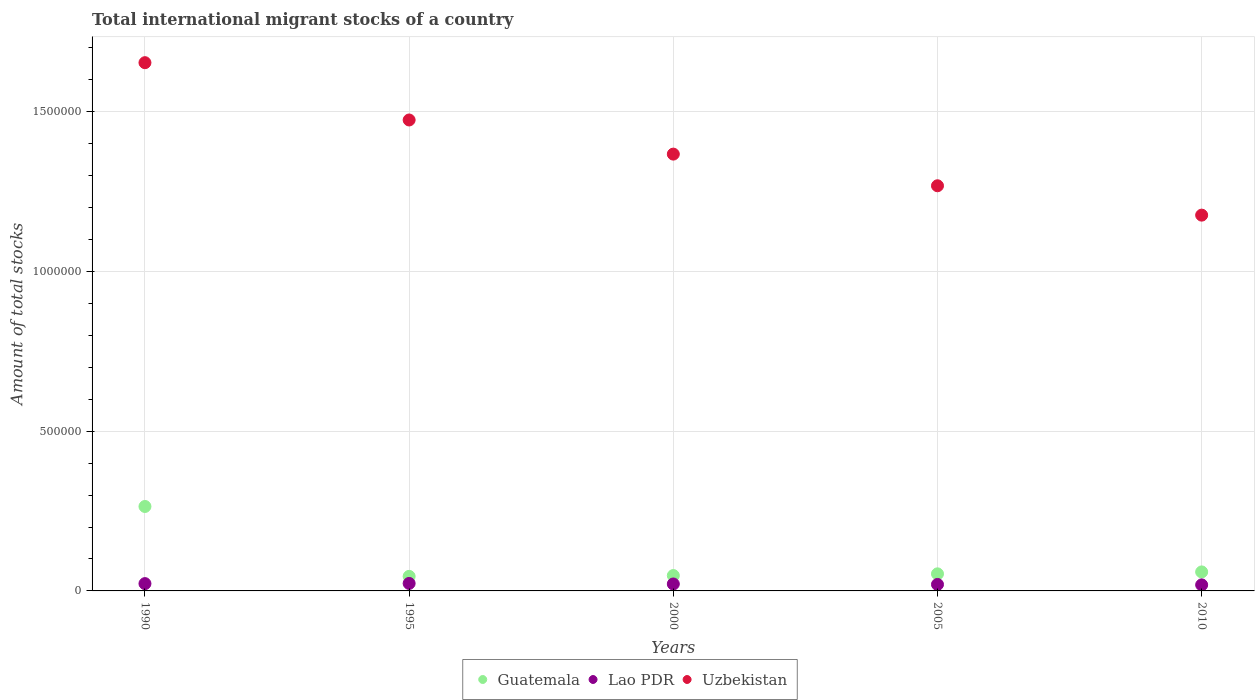How many different coloured dotlines are there?
Provide a short and direct response. 3. Is the number of dotlines equal to the number of legend labels?
Make the answer very short. Yes. What is the amount of total stocks in in Guatemala in 1990?
Ensure brevity in your answer.  2.64e+05. Across all years, what is the maximum amount of total stocks in in Guatemala?
Offer a very short reply. 2.64e+05. Across all years, what is the minimum amount of total stocks in in Guatemala?
Your response must be concise. 4.55e+04. In which year was the amount of total stocks in in Lao PDR minimum?
Offer a very short reply. 2010. What is the total amount of total stocks in in Lao PDR in the graph?
Your answer should be very brief. 1.07e+05. What is the difference between the amount of total stocks in in Uzbekistan in 1990 and that in 2010?
Offer a very short reply. 4.77e+05. What is the difference between the amount of total stocks in in Uzbekistan in 2000 and the amount of total stocks in in Lao PDR in 2010?
Offer a terse response. 1.35e+06. What is the average amount of total stocks in in Guatemala per year?
Your response must be concise. 9.42e+04. In the year 2005, what is the difference between the amount of total stocks in in Uzbekistan and amount of total stocks in in Guatemala?
Your response must be concise. 1.21e+06. What is the ratio of the amount of total stocks in in Guatemala in 2000 to that in 2010?
Provide a short and direct response. 0.81. What is the difference between the highest and the second highest amount of total stocks in in Guatemala?
Your response must be concise. 2.05e+05. What is the difference between the highest and the lowest amount of total stocks in in Lao PDR?
Provide a short and direct response. 4529. Is it the case that in every year, the sum of the amount of total stocks in in Lao PDR and amount of total stocks in in Uzbekistan  is greater than the amount of total stocks in in Guatemala?
Your answer should be very brief. Yes. Does the amount of total stocks in in Lao PDR monotonically increase over the years?
Offer a very short reply. No. What is the difference between two consecutive major ticks on the Y-axis?
Your answer should be very brief. 5.00e+05. Are the values on the major ticks of Y-axis written in scientific E-notation?
Your response must be concise. No. How many legend labels are there?
Provide a succinct answer. 3. How are the legend labels stacked?
Give a very brief answer. Horizontal. What is the title of the graph?
Give a very brief answer. Total international migrant stocks of a country. Does "Turkmenistan" appear as one of the legend labels in the graph?
Make the answer very short. No. What is the label or title of the Y-axis?
Make the answer very short. Amount of total stocks. What is the Amount of total stocks in Guatemala in 1990?
Keep it short and to the point. 2.64e+05. What is the Amount of total stocks of Lao PDR in 1990?
Provide a short and direct response. 2.29e+04. What is the Amount of total stocks in Uzbekistan in 1990?
Your answer should be compact. 1.65e+06. What is the Amount of total stocks of Guatemala in 1995?
Offer a very short reply. 4.55e+04. What is the Amount of total stocks of Lao PDR in 1995?
Make the answer very short. 2.34e+04. What is the Amount of total stocks of Uzbekistan in 1995?
Ensure brevity in your answer.  1.47e+06. What is the Amount of total stocks in Guatemala in 2000?
Provide a short and direct response. 4.81e+04. What is the Amount of total stocks in Lao PDR in 2000?
Offer a terse response. 2.17e+04. What is the Amount of total stocks of Uzbekistan in 2000?
Offer a very short reply. 1.37e+06. What is the Amount of total stocks of Guatemala in 2005?
Your response must be concise. 5.34e+04. What is the Amount of total stocks of Lao PDR in 2005?
Your answer should be very brief. 2.03e+04. What is the Amount of total stocks in Uzbekistan in 2005?
Your answer should be compact. 1.27e+06. What is the Amount of total stocks of Guatemala in 2010?
Your answer should be very brief. 5.95e+04. What is the Amount of total stocks in Lao PDR in 2010?
Offer a terse response. 1.89e+04. What is the Amount of total stocks of Uzbekistan in 2010?
Your response must be concise. 1.18e+06. Across all years, what is the maximum Amount of total stocks of Guatemala?
Offer a terse response. 2.64e+05. Across all years, what is the maximum Amount of total stocks of Lao PDR?
Your answer should be compact. 2.34e+04. Across all years, what is the maximum Amount of total stocks in Uzbekistan?
Offer a very short reply. 1.65e+06. Across all years, what is the minimum Amount of total stocks in Guatemala?
Your response must be concise. 4.55e+04. Across all years, what is the minimum Amount of total stocks in Lao PDR?
Provide a succinct answer. 1.89e+04. Across all years, what is the minimum Amount of total stocks of Uzbekistan?
Offer a very short reply. 1.18e+06. What is the total Amount of total stocks in Guatemala in the graph?
Provide a succinct answer. 4.71e+05. What is the total Amount of total stocks of Lao PDR in the graph?
Keep it short and to the point. 1.07e+05. What is the total Amount of total stocks of Uzbekistan in the graph?
Ensure brevity in your answer.  6.94e+06. What is the difference between the Amount of total stocks in Guatemala in 1990 and that in 1995?
Ensure brevity in your answer.  2.19e+05. What is the difference between the Amount of total stocks in Lao PDR in 1990 and that in 1995?
Provide a succinct answer. -579. What is the difference between the Amount of total stocks of Uzbekistan in 1990 and that in 1995?
Your response must be concise. 1.79e+05. What is the difference between the Amount of total stocks in Guatemala in 1990 and that in 2000?
Your response must be concise. 2.16e+05. What is the difference between the Amount of total stocks in Lao PDR in 1990 and that in 2000?
Provide a succinct answer. 1132. What is the difference between the Amount of total stocks of Uzbekistan in 1990 and that in 2000?
Your answer should be very brief. 2.86e+05. What is the difference between the Amount of total stocks in Guatemala in 1990 and that in 2005?
Give a very brief answer. 2.11e+05. What is the difference between the Amount of total stocks in Lao PDR in 1990 and that in 2005?
Provide a succinct answer. 2590. What is the difference between the Amount of total stocks of Uzbekistan in 1990 and that in 2005?
Provide a succinct answer. 3.85e+05. What is the difference between the Amount of total stocks of Guatemala in 1990 and that in 2010?
Offer a terse response. 2.05e+05. What is the difference between the Amount of total stocks of Lao PDR in 1990 and that in 2010?
Your answer should be compact. 3950. What is the difference between the Amount of total stocks of Uzbekistan in 1990 and that in 2010?
Ensure brevity in your answer.  4.77e+05. What is the difference between the Amount of total stocks of Guatemala in 1995 and that in 2000?
Provide a succinct answer. -2586. What is the difference between the Amount of total stocks in Lao PDR in 1995 and that in 2000?
Provide a succinct answer. 1711. What is the difference between the Amount of total stocks of Uzbekistan in 1995 and that in 2000?
Keep it short and to the point. 1.07e+05. What is the difference between the Amount of total stocks in Guatemala in 1995 and that in 2005?
Ensure brevity in your answer.  -7904. What is the difference between the Amount of total stocks of Lao PDR in 1995 and that in 2005?
Give a very brief answer. 3169. What is the difference between the Amount of total stocks in Uzbekistan in 1995 and that in 2005?
Your answer should be compact. 2.06e+05. What is the difference between the Amount of total stocks in Guatemala in 1995 and that in 2010?
Your answer should be very brief. -1.39e+04. What is the difference between the Amount of total stocks of Lao PDR in 1995 and that in 2010?
Your answer should be compact. 4529. What is the difference between the Amount of total stocks of Uzbekistan in 1995 and that in 2010?
Provide a succinct answer. 2.98e+05. What is the difference between the Amount of total stocks in Guatemala in 2000 and that in 2005?
Your answer should be compact. -5318. What is the difference between the Amount of total stocks in Lao PDR in 2000 and that in 2005?
Provide a succinct answer. 1458. What is the difference between the Amount of total stocks in Uzbekistan in 2000 and that in 2005?
Offer a very short reply. 9.91e+04. What is the difference between the Amount of total stocks of Guatemala in 2000 and that in 2010?
Give a very brief answer. -1.13e+04. What is the difference between the Amount of total stocks in Lao PDR in 2000 and that in 2010?
Offer a very short reply. 2818. What is the difference between the Amount of total stocks in Uzbekistan in 2000 and that in 2010?
Offer a terse response. 1.91e+05. What is the difference between the Amount of total stocks of Guatemala in 2005 and that in 2010?
Offer a terse response. -6020. What is the difference between the Amount of total stocks in Lao PDR in 2005 and that in 2010?
Make the answer very short. 1360. What is the difference between the Amount of total stocks of Uzbekistan in 2005 and that in 2010?
Keep it short and to the point. 9.19e+04. What is the difference between the Amount of total stocks in Guatemala in 1990 and the Amount of total stocks in Lao PDR in 1995?
Ensure brevity in your answer.  2.41e+05. What is the difference between the Amount of total stocks in Guatemala in 1990 and the Amount of total stocks in Uzbekistan in 1995?
Provide a succinct answer. -1.21e+06. What is the difference between the Amount of total stocks in Lao PDR in 1990 and the Amount of total stocks in Uzbekistan in 1995?
Keep it short and to the point. -1.45e+06. What is the difference between the Amount of total stocks in Guatemala in 1990 and the Amount of total stocks in Lao PDR in 2000?
Make the answer very short. 2.43e+05. What is the difference between the Amount of total stocks in Guatemala in 1990 and the Amount of total stocks in Uzbekistan in 2000?
Your answer should be compact. -1.10e+06. What is the difference between the Amount of total stocks in Lao PDR in 1990 and the Amount of total stocks in Uzbekistan in 2000?
Keep it short and to the point. -1.34e+06. What is the difference between the Amount of total stocks in Guatemala in 1990 and the Amount of total stocks in Lao PDR in 2005?
Offer a terse response. 2.44e+05. What is the difference between the Amount of total stocks of Guatemala in 1990 and the Amount of total stocks of Uzbekistan in 2005?
Your answer should be compact. -1.00e+06. What is the difference between the Amount of total stocks of Lao PDR in 1990 and the Amount of total stocks of Uzbekistan in 2005?
Offer a terse response. -1.24e+06. What is the difference between the Amount of total stocks in Guatemala in 1990 and the Amount of total stocks in Lao PDR in 2010?
Provide a short and direct response. 2.45e+05. What is the difference between the Amount of total stocks of Guatemala in 1990 and the Amount of total stocks of Uzbekistan in 2010?
Offer a terse response. -9.12e+05. What is the difference between the Amount of total stocks in Lao PDR in 1990 and the Amount of total stocks in Uzbekistan in 2010?
Provide a short and direct response. -1.15e+06. What is the difference between the Amount of total stocks in Guatemala in 1995 and the Amount of total stocks in Lao PDR in 2000?
Provide a short and direct response. 2.38e+04. What is the difference between the Amount of total stocks in Guatemala in 1995 and the Amount of total stocks in Uzbekistan in 2000?
Offer a terse response. -1.32e+06. What is the difference between the Amount of total stocks of Lao PDR in 1995 and the Amount of total stocks of Uzbekistan in 2000?
Provide a succinct answer. -1.34e+06. What is the difference between the Amount of total stocks of Guatemala in 1995 and the Amount of total stocks of Lao PDR in 2005?
Offer a very short reply. 2.53e+04. What is the difference between the Amount of total stocks in Guatemala in 1995 and the Amount of total stocks in Uzbekistan in 2005?
Your answer should be compact. -1.22e+06. What is the difference between the Amount of total stocks in Lao PDR in 1995 and the Amount of total stocks in Uzbekistan in 2005?
Ensure brevity in your answer.  -1.24e+06. What is the difference between the Amount of total stocks in Guatemala in 1995 and the Amount of total stocks in Lao PDR in 2010?
Your answer should be very brief. 2.66e+04. What is the difference between the Amount of total stocks of Guatemala in 1995 and the Amount of total stocks of Uzbekistan in 2010?
Keep it short and to the point. -1.13e+06. What is the difference between the Amount of total stocks in Lao PDR in 1995 and the Amount of total stocks in Uzbekistan in 2010?
Provide a short and direct response. -1.15e+06. What is the difference between the Amount of total stocks of Guatemala in 2000 and the Amount of total stocks of Lao PDR in 2005?
Your answer should be very brief. 2.78e+04. What is the difference between the Amount of total stocks of Guatemala in 2000 and the Amount of total stocks of Uzbekistan in 2005?
Provide a succinct answer. -1.22e+06. What is the difference between the Amount of total stocks in Lao PDR in 2000 and the Amount of total stocks in Uzbekistan in 2005?
Give a very brief answer. -1.25e+06. What is the difference between the Amount of total stocks of Guatemala in 2000 and the Amount of total stocks of Lao PDR in 2010?
Offer a terse response. 2.92e+04. What is the difference between the Amount of total stocks of Guatemala in 2000 and the Amount of total stocks of Uzbekistan in 2010?
Offer a very short reply. -1.13e+06. What is the difference between the Amount of total stocks of Lao PDR in 2000 and the Amount of total stocks of Uzbekistan in 2010?
Give a very brief answer. -1.15e+06. What is the difference between the Amount of total stocks of Guatemala in 2005 and the Amount of total stocks of Lao PDR in 2010?
Your answer should be very brief. 3.45e+04. What is the difference between the Amount of total stocks of Guatemala in 2005 and the Amount of total stocks of Uzbekistan in 2010?
Provide a short and direct response. -1.12e+06. What is the difference between the Amount of total stocks in Lao PDR in 2005 and the Amount of total stocks in Uzbekistan in 2010?
Make the answer very short. -1.16e+06. What is the average Amount of total stocks in Guatemala per year?
Your response must be concise. 9.42e+04. What is the average Amount of total stocks in Lao PDR per year?
Give a very brief answer. 2.14e+04. What is the average Amount of total stocks in Uzbekistan per year?
Offer a very short reply. 1.39e+06. In the year 1990, what is the difference between the Amount of total stocks of Guatemala and Amount of total stocks of Lao PDR?
Your answer should be very brief. 2.41e+05. In the year 1990, what is the difference between the Amount of total stocks of Guatemala and Amount of total stocks of Uzbekistan?
Offer a very short reply. -1.39e+06. In the year 1990, what is the difference between the Amount of total stocks in Lao PDR and Amount of total stocks in Uzbekistan?
Provide a short and direct response. -1.63e+06. In the year 1995, what is the difference between the Amount of total stocks in Guatemala and Amount of total stocks in Lao PDR?
Make the answer very short. 2.21e+04. In the year 1995, what is the difference between the Amount of total stocks in Guatemala and Amount of total stocks in Uzbekistan?
Make the answer very short. -1.43e+06. In the year 1995, what is the difference between the Amount of total stocks in Lao PDR and Amount of total stocks in Uzbekistan?
Offer a very short reply. -1.45e+06. In the year 2000, what is the difference between the Amount of total stocks in Guatemala and Amount of total stocks in Lao PDR?
Give a very brief answer. 2.64e+04. In the year 2000, what is the difference between the Amount of total stocks in Guatemala and Amount of total stocks in Uzbekistan?
Your answer should be very brief. -1.32e+06. In the year 2000, what is the difference between the Amount of total stocks in Lao PDR and Amount of total stocks in Uzbekistan?
Offer a terse response. -1.35e+06. In the year 2005, what is the difference between the Amount of total stocks of Guatemala and Amount of total stocks of Lao PDR?
Give a very brief answer. 3.32e+04. In the year 2005, what is the difference between the Amount of total stocks of Guatemala and Amount of total stocks of Uzbekistan?
Offer a terse response. -1.21e+06. In the year 2005, what is the difference between the Amount of total stocks in Lao PDR and Amount of total stocks in Uzbekistan?
Ensure brevity in your answer.  -1.25e+06. In the year 2010, what is the difference between the Amount of total stocks of Guatemala and Amount of total stocks of Lao PDR?
Provide a short and direct response. 4.05e+04. In the year 2010, what is the difference between the Amount of total stocks in Guatemala and Amount of total stocks in Uzbekistan?
Your answer should be very brief. -1.12e+06. In the year 2010, what is the difference between the Amount of total stocks in Lao PDR and Amount of total stocks in Uzbekistan?
Make the answer very short. -1.16e+06. What is the ratio of the Amount of total stocks of Guatemala in 1990 to that in 1995?
Ensure brevity in your answer.  5.8. What is the ratio of the Amount of total stocks of Lao PDR in 1990 to that in 1995?
Your response must be concise. 0.98. What is the ratio of the Amount of total stocks of Uzbekistan in 1990 to that in 1995?
Ensure brevity in your answer.  1.12. What is the ratio of the Amount of total stocks in Guatemala in 1990 to that in 2000?
Your response must be concise. 5.49. What is the ratio of the Amount of total stocks of Lao PDR in 1990 to that in 2000?
Ensure brevity in your answer.  1.05. What is the ratio of the Amount of total stocks of Uzbekistan in 1990 to that in 2000?
Ensure brevity in your answer.  1.21. What is the ratio of the Amount of total stocks of Guatemala in 1990 to that in 2005?
Make the answer very short. 4.95. What is the ratio of the Amount of total stocks in Lao PDR in 1990 to that in 2005?
Your answer should be compact. 1.13. What is the ratio of the Amount of total stocks of Uzbekistan in 1990 to that in 2005?
Provide a succinct answer. 1.3. What is the ratio of the Amount of total stocks in Guatemala in 1990 to that in 2010?
Offer a very short reply. 4.44. What is the ratio of the Amount of total stocks in Lao PDR in 1990 to that in 2010?
Offer a very short reply. 1.21. What is the ratio of the Amount of total stocks in Uzbekistan in 1990 to that in 2010?
Offer a very short reply. 1.41. What is the ratio of the Amount of total stocks in Guatemala in 1995 to that in 2000?
Make the answer very short. 0.95. What is the ratio of the Amount of total stocks in Lao PDR in 1995 to that in 2000?
Ensure brevity in your answer.  1.08. What is the ratio of the Amount of total stocks in Uzbekistan in 1995 to that in 2000?
Give a very brief answer. 1.08. What is the ratio of the Amount of total stocks in Guatemala in 1995 to that in 2005?
Make the answer very short. 0.85. What is the ratio of the Amount of total stocks in Lao PDR in 1995 to that in 2005?
Offer a very short reply. 1.16. What is the ratio of the Amount of total stocks of Uzbekistan in 1995 to that in 2005?
Offer a very short reply. 1.16. What is the ratio of the Amount of total stocks in Guatemala in 1995 to that in 2010?
Ensure brevity in your answer.  0.77. What is the ratio of the Amount of total stocks in Lao PDR in 1995 to that in 2010?
Your answer should be compact. 1.24. What is the ratio of the Amount of total stocks of Uzbekistan in 1995 to that in 2010?
Your response must be concise. 1.25. What is the ratio of the Amount of total stocks in Guatemala in 2000 to that in 2005?
Make the answer very short. 0.9. What is the ratio of the Amount of total stocks in Lao PDR in 2000 to that in 2005?
Your answer should be compact. 1.07. What is the ratio of the Amount of total stocks of Uzbekistan in 2000 to that in 2005?
Make the answer very short. 1.08. What is the ratio of the Amount of total stocks of Guatemala in 2000 to that in 2010?
Your response must be concise. 0.81. What is the ratio of the Amount of total stocks in Lao PDR in 2000 to that in 2010?
Offer a terse response. 1.15. What is the ratio of the Amount of total stocks of Uzbekistan in 2000 to that in 2010?
Make the answer very short. 1.16. What is the ratio of the Amount of total stocks in Guatemala in 2005 to that in 2010?
Give a very brief answer. 0.9. What is the ratio of the Amount of total stocks of Lao PDR in 2005 to that in 2010?
Your response must be concise. 1.07. What is the ratio of the Amount of total stocks of Uzbekistan in 2005 to that in 2010?
Offer a terse response. 1.08. What is the difference between the highest and the second highest Amount of total stocks in Guatemala?
Keep it short and to the point. 2.05e+05. What is the difference between the highest and the second highest Amount of total stocks in Lao PDR?
Offer a terse response. 579. What is the difference between the highest and the second highest Amount of total stocks in Uzbekistan?
Offer a very short reply. 1.79e+05. What is the difference between the highest and the lowest Amount of total stocks of Guatemala?
Your answer should be very brief. 2.19e+05. What is the difference between the highest and the lowest Amount of total stocks of Lao PDR?
Keep it short and to the point. 4529. What is the difference between the highest and the lowest Amount of total stocks in Uzbekistan?
Your response must be concise. 4.77e+05. 